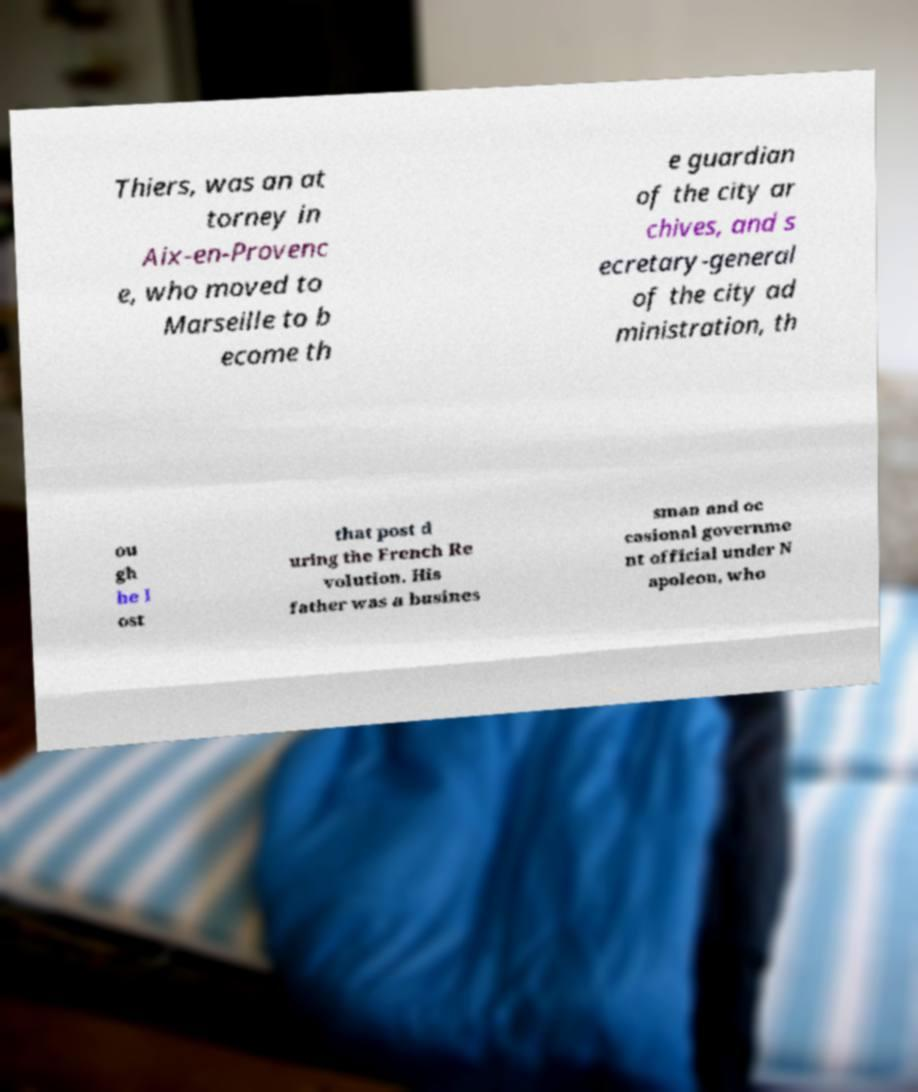Please identify and transcribe the text found in this image. Thiers, was an at torney in Aix-en-Provenc e, who moved to Marseille to b ecome th e guardian of the city ar chives, and s ecretary-general of the city ad ministration, th ou gh he l ost that post d uring the French Re volution. His father was a busines sman and oc casional governme nt official under N apoleon, who 